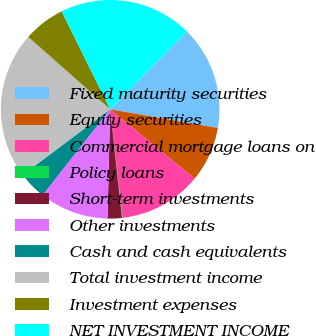Convert chart. <chart><loc_0><loc_0><loc_500><loc_500><pie_chart><fcel>Fixed maturity securities<fcel>Equity securities<fcel>Commercial mortgage loans on<fcel>Policy loans<fcel>Short-term investments<fcel>Other investments<fcel>Cash and cash equivalents<fcel>Total investment income<fcel>Investment expenses<fcel>NET INVESTMENT INCOME<nl><fcel>15.32%<fcel>8.2%<fcel>12.25%<fcel>0.09%<fcel>2.12%<fcel>10.22%<fcel>4.14%<fcel>21.76%<fcel>6.17%<fcel>19.74%<nl></chart> 